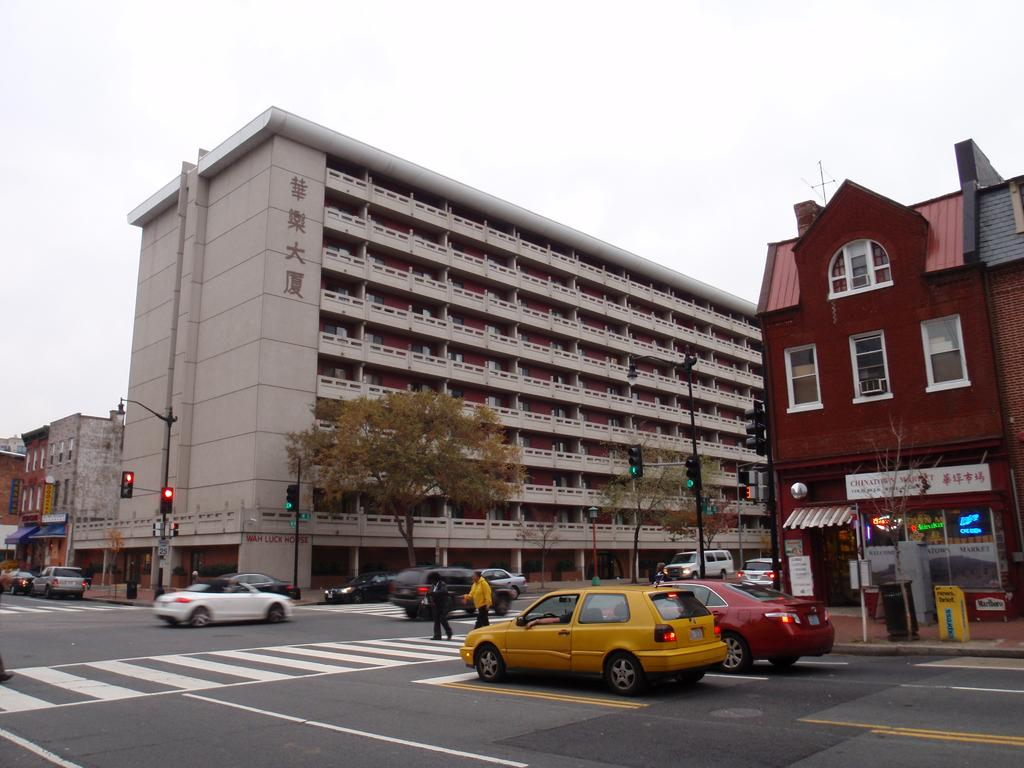What type of vehicles can be seen on the road in the image? There are cars on the road in the image. What natural elements are visible in the image? Trees are visible in the image. What structures are present in the image? Poles, traffic signals, a bin, boards, and buildings are present in the image. How many people are on the road in the image? There are two persons on the road in the image. What part of the environment can be seen in the background of the image? The sky is visible in the background of the image. Can you tell me where the aunt is standing in the image? There is no aunt present in the image. What is the elbow doing in the image? There is no elbow present in the image. 